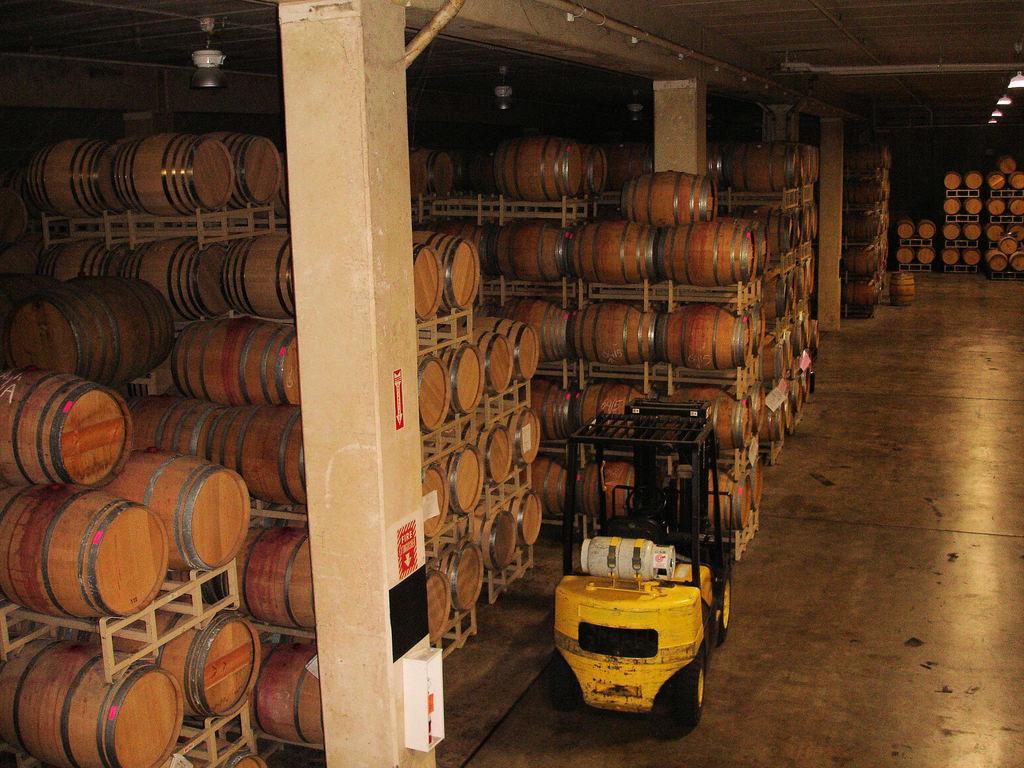Please provide a concise description of this image. This picture is taken inside the room. In this image, on the left side, we can see a pillar and a shelf with some instrument. In the middle of the image, we can also see a vehicle which is placed on the floor. On the right side, we can also see a shelf with some objects. At the top, we can see a roof with few lights, at the bottom, we can see a floor. 